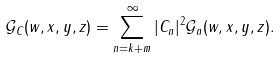Convert formula to latex. <formula><loc_0><loc_0><loc_500><loc_500>\mathcal { G } _ { C } ( w , x , y , z ) = \sum _ { n = k + m } ^ { \infty } | C _ { n } | ^ { 2 } \mathcal { G } _ { n } ( w , x , y , z ) .</formula> 